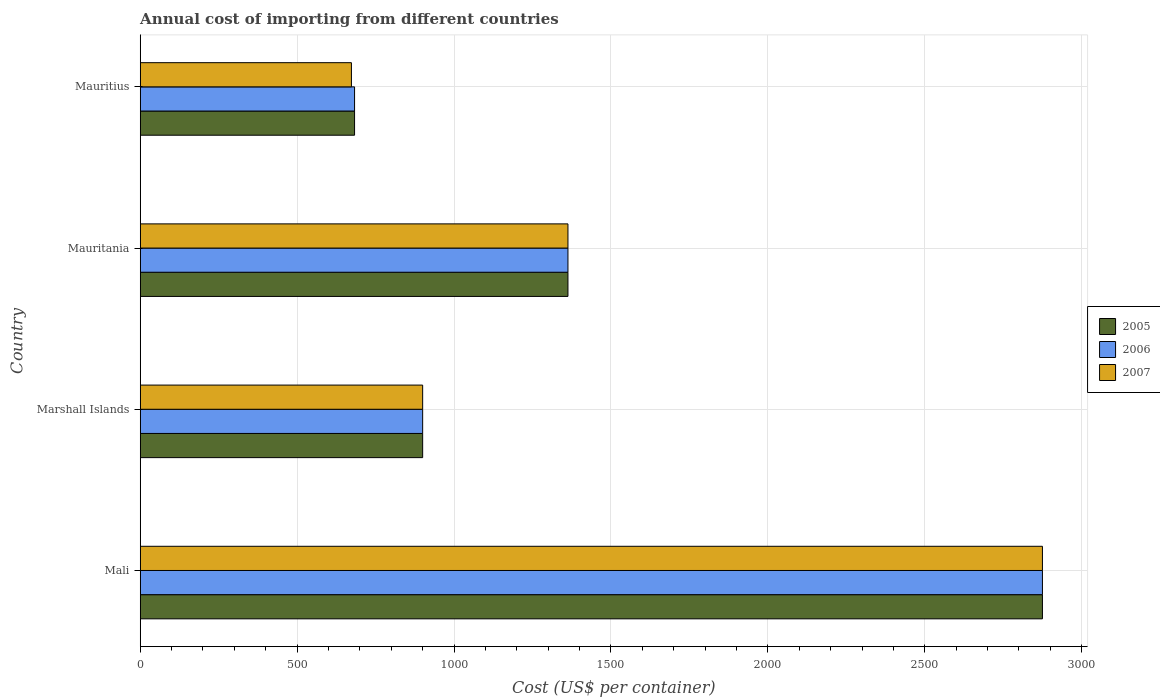How many different coloured bars are there?
Your answer should be very brief. 3. Are the number of bars on each tick of the Y-axis equal?
Your answer should be very brief. Yes. How many bars are there on the 4th tick from the top?
Keep it short and to the point. 3. How many bars are there on the 3rd tick from the bottom?
Give a very brief answer. 3. What is the label of the 4th group of bars from the top?
Provide a succinct answer. Mali. What is the total annual cost of importing in 2005 in Mauritius?
Your response must be concise. 683. Across all countries, what is the maximum total annual cost of importing in 2005?
Your response must be concise. 2875. Across all countries, what is the minimum total annual cost of importing in 2007?
Ensure brevity in your answer.  673. In which country was the total annual cost of importing in 2005 maximum?
Offer a very short reply. Mali. In which country was the total annual cost of importing in 2006 minimum?
Your response must be concise. Mauritius. What is the total total annual cost of importing in 2007 in the graph?
Give a very brief answer. 5811. What is the difference between the total annual cost of importing in 2007 in Mali and that in Marshall Islands?
Offer a terse response. 1975. What is the difference between the total annual cost of importing in 2005 in Mauritius and the total annual cost of importing in 2006 in Mali?
Offer a very short reply. -2192. What is the average total annual cost of importing in 2006 per country?
Give a very brief answer. 1455.25. What is the difference between the total annual cost of importing in 2006 and total annual cost of importing in 2005 in Mali?
Your answer should be compact. 0. In how many countries, is the total annual cost of importing in 2005 greater than 400 US$?
Keep it short and to the point. 4. What is the ratio of the total annual cost of importing in 2007 in Mali to that in Marshall Islands?
Your answer should be very brief. 3.19. Is the total annual cost of importing in 2007 in Marshall Islands less than that in Mauritania?
Provide a short and direct response. Yes. What is the difference between the highest and the second highest total annual cost of importing in 2007?
Make the answer very short. 1512. What is the difference between the highest and the lowest total annual cost of importing in 2007?
Give a very brief answer. 2202. What does the 2nd bar from the top in Marshall Islands represents?
Provide a short and direct response. 2006. Is it the case that in every country, the sum of the total annual cost of importing in 2005 and total annual cost of importing in 2006 is greater than the total annual cost of importing in 2007?
Make the answer very short. Yes. How many countries are there in the graph?
Provide a short and direct response. 4. Does the graph contain any zero values?
Your response must be concise. No. Does the graph contain grids?
Make the answer very short. Yes. How are the legend labels stacked?
Your answer should be very brief. Vertical. What is the title of the graph?
Keep it short and to the point. Annual cost of importing from different countries. Does "1969" appear as one of the legend labels in the graph?
Offer a very short reply. No. What is the label or title of the X-axis?
Provide a short and direct response. Cost (US$ per container). What is the label or title of the Y-axis?
Provide a short and direct response. Country. What is the Cost (US$ per container) in 2005 in Mali?
Ensure brevity in your answer.  2875. What is the Cost (US$ per container) in 2006 in Mali?
Ensure brevity in your answer.  2875. What is the Cost (US$ per container) of 2007 in Mali?
Provide a succinct answer. 2875. What is the Cost (US$ per container) in 2005 in Marshall Islands?
Your response must be concise. 900. What is the Cost (US$ per container) in 2006 in Marshall Islands?
Provide a short and direct response. 900. What is the Cost (US$ per container) in 2007 in Marshall Islands?
Give a very brief answer. 900. What is the Cost (US$ per container) of 2005 in Mauritania?
Your answer should be compact. 1363. What is the Cost (US$ per container) in 2006 in Mauritania?
Your response must be concise. 1363. What is the Cost (US$ per container) in 2007 in Mauritania?
Offer a terse response. 1363. What is the Cost (US$ per container) of 2005 in Mauritius?
Keep it short and to the point. 683. What is the Cost (US$ per container) in 2006 in Mauritius?
Offer a terse response. 683. What is the Cost (US$ per container) in 2007 in Mauritius?
Provide a short and direct response. 673. Across all countries, what is the maximum Cost (US$ per container) in 2005?
Your response must be concise. 2875. Across all countries, what is the maximum Cost (US$ per container) in 2006?
Your answer should be compact. 2875. Across all countries, what is the maximum Cost (US$ per container) in 2007?
Make the answer very short. 2875. Across all countries, what is the minimum Cost (US$ per container) in 2005?
Your response must be concise. 683. Across all countries, what is the minimum Cost (US$ per container) in 2006?
Offer a very short reply. 683. Across all countries, what is the minimum Cost (US$ per container) of 2007?
Offer a terse response. 673. What is the total Cost (US$ per container) in 2005 in the graph?
Keep it short and to the point. 5821. What is the total Cost (US$ per container) of 2006 in the graph?
Offer a very short reply. 5821. What is the total Cost (US$ per container) in 2007 in the graph?
Make the answer very short. 5811. What is the difference between the Cost (US$ per container) of 2005 in Mali and that in Marshall Islands?
Provide a succinct answer. 1975. What is the difference between the Cost (US$ per container) of 2006 in Mali and that in Marshall Islands?
Offer a terse response. 1975. What is the difference between the Cost (US$ per container) of 2007 in Mali and that in Marshall Islands?
Offer a very short reply. 1975. What is the difference between the Cost (US$ per container) in 2005 in Mali and that in Mauritania?
Make the answer very short. 1512. What is the difference between the Cost (US$ per container) in 2006 in Mali and that in Mauritania?
Ensure brevity in your answer.  1512. What is the difference between the Cost (US$ per container) in 2007 in Mali and that in Mauritania?
Provide a short and direct response. 1512. What is the difference between the Cost (US$ per container) in 2005 in Mali and that in Mauritius?
Offer a terse response. 2192. What is the difference between the Cost (US$ per container) in 2006 in Mali and that in Mauritius?
Ensure brevity in your answer.  2192. What is the difference between the Cost (US$ per container) in 2007 in Mali and that in Mauritius?
Ensure brevity in your answer.  2202. What is the difference between the Cost (US$ per container) of 2005 in Marshall Islands and that in Mauritania?
Your answer should be very brief. -463. What is the difference between the Cost (US$ per container) of 2006 in Marshall Islands and that in Mauritania?
Your answer should be compact. -463. What is the difference between the Cost (US$ per container) of 2007 in Marshall Islands and that in Mauritania?
Ensure brevity in your answer.  -463. What is the difference between the Cost (US$ per container) of 2005 in Marshall Islands and that in Mauritius?
Offer a terse response. 217. What is the difference between the Cost (US$ per container) in 2006 in Marshall Islands and that in Mauritius?
Your answer should be compact. 217. What is the difference between the Cost (US$ per container) in 2007 in Marshall Islands and that in Mauritius?
Give a very brief answer. 227. What is the difference between the Cost (US$ per container) in 2005 in Mauritania and that in Mauritius?
Give a very brief answer. 680. What is the difference between the Cost (US$ per container) of 2006 in Mauritania and that in Mauritius?
Keep it short and to the point. 680. What is the difference between the Cost (US$ per container) in 2007 in Mauritania and that in Mauritius?
Offer a very short reply. 690. What is the difference between the Cost (US$ per container) in 2005 in Mali and the Cost (US$ per container) in 2006 in Marshall Islands?
Your answer should be compact. 1975. What is the difference between the Cost (US$ per container) of 2005 in Mali and the Cost (US$ per container) of 2007 in Marshall Islands?
Give a very brief answer. 1975. What is the difference between the Cost (US$ per container) in 2006 in Mali and the Cost (US$ per container) in 2007 in Marshall Islands?
Keep it short and to the point. 1975. What is the difference between the Cost (US$ per container) of 2005 in Mali and the Cost (US$ per container) of 2006 in Mauritania?
Ensure brevity in your answer.  1512. What is the difference between the Cost (US$ per container) in 2005 in Mali and the Cost (US$ per container) in 2007 in Mauritania?
Give a very brief answer. 1512. What is the difference between the Cost (US$ per container) of 2006 in Mali and the Cost (US$ per container) of 2007 in Mauritania?
Keep it short and to the point. 1512. What is the difference between the Cost (US$ per container) in 2005 in Mali and the Cost (US$ per container) in 2006 in Mauritius?
Provide a short and direct response. 2192. What is the difference between the Cost (US$ per container) in 2005 in Mali and the Cost (US$ per container) in 2007 in Mauritius?
Your answer should be compact. 2202. What is the difference between the Cost (US$ per container) in 2006 in Mali and the Cost (US$ per container) in 2007 in Mauritius?
Make the answer very short. 2202. What is the difference between the Cost (US$ per container) of 2005 in Marshall Islands and the Cost (US$ per container) of 2006 in Mauritania?
Make the answer very short. -463. What is the difference between the Cost (US$ per container) in 2005 in Marshall Islands and the Cost (US$ per container) in 2007 in Mauritania?
Your answer should be very brief. -463. What is the difference between the Cost (US$ per container) of 2006 in Marshall Islands and the Cost (US$ per container) of 2007 in Mauritania?
Give a very brief answer. -463. What is the difference between the Cost (US$ per container) of 2005 in Marshall Islands and the Cost (US$ per container) of 2006 in Mauritius?
Provide a short and direct response. 217. What is the difference between the Cost (US$ per container) of 2005 in Marshall Islands and the Cost (US$ per container) of 2007 in Mauritius?
Offer a terse response. 227. What is the difference between the Cost (US$ per container) of 2006 in Marshall Islands and the Cost (US$ per container) of 2007 in Mauritius?
Offer a terse response. 227. What is the difference between the Cost (US$ per container) of 2005 in Mauritania and the Cost (US$ per container) of 2006 in Mauritius?
Your response must be concise. 680. What is the difference between the Cost (US$ per container) in 2005 in Mauritania and the Cost (US$ per container) in 2007 in Mauritius?
Provide a short and direct response. 690. What is the difference between the Cost (US$ per container) of 2006 in Mauritania and the Cost (US$ per container) of 2007 in Mauritius?
Your response must be concise. 690. What is the average Cost (US$ per container) in 2005 per country?
Make the answer very short. 1455.25. What is the average Cost (US$ per container) in 2006 per country?
Your answer should be very brief. 1455.25. What is the average Cost (US$ per container) of 2007 per country?
Make the answer very short. 1452.75. What is the difference between the Cost (US$ per container) of 2005 and Cost (US$ per container) of 2006 in Mali?
Give a very brief answer. 0. What is the difference between the Cost (US$ per container) in 2005 and Cost (US$ per container) in 2007 in Mali?
Ensure brevity in your answer.  0. What is the difference between the Cost (US$ per container) of 2006 and Cost (US$ per container) of 2007 in Mali?
Keep it short and to the point. 0. What is the difference between the Cost (US$ per container) in 2005 and Cost (US$ per container) in 2007 in Marshall Islands?
Offer a very short reply. 0. What is the difference between the Cost (US$ per container) of 2006 and Cost (US$ per container) of 2007 in Marshall Islands?
Give a very brief answer. 0. What is the difference between the Cost (US$ per container) in 2005 and Cost (US$ per container) in 2006 in Mauritania?
Provide a short and direct response. 0. What is the difference between the Cost (US$ per container) of 2005 and Cost (US$ per container) of 2006 in Mauritius?
Ensure brevity in your answer.  0. What is the difference between the Cost (US$ per container) in 2005 and Cost (US$ per container) in 2007 in Mauritius?
Provide a succinct answer. 10. What is the difference between the Cost (US$ per container) of 2006 and Cost (US$ per container) of 2007 in Mauritius?
Your answer should be compact. 10. What is the ratio of the Cost (US$ per container) in 2005 in Mali to that in Marshall Islands?
Make the answer very short. 3.19. What is the ratio of the Cost (US$ per container) in 2006 in Mali to that in Marshall Islands?
Provide a short and direct response. 3.19. What is the ratio of the Cost (US$ per container) in 2007 in Mali to that in Marshall Islands?
Your answer should be compact. 3.19. What is the ratio of the Cost (US$ per container) in 2005 in Mali to that in Mauritania?
Offer a very short reply. 2.11. What is the ratio of the Cost (US$ per container) in 2006 in Mali to that in Mauritania?
Give a very brief answer. 2.11. What is the ratio of the Cost (US$ per container) of 2007 in Mali to that in Mauritania?
Your response must be concise. 2.11. What is the ratio of the Cost (US$ per container) of 2005 in Mali to that in Mauritius?
Offer a very short reply. 4.21. What is the ratio of the Cost (US$ per container) of 2006 in Mali to that in Mauritius?
Ensure brevity in your answer.  4.21. What is the ratio of the Cost (US$ per container) of 2007 in Mali to that in Mauritius?
Ensure brevity in your answer.  4.27. What is the ratio of the Cost (US$ per container) of 2005 in Marshall Islands to that in Mauritania?
Keep it short and to the point. 0.66. What is the ratio of the Cost (US$ per container) in 2006 in Marshall Islands to that in Mauritania?
Your response must be concise. 0.66. What is the ratio of the Cost (US$ per container) in 2007 in Marshall Islands to that in Mauritania?
Provide a short and direct response. 0.66. What is the ratio of the Cost (US$ per container) in 2005 in Marshall Islands to that in Mauritius?
Offer a terse response. 1.32. What is the ratio of the Cost (US$ per container) of 2006 in Marshall Islands to that in Mauritius?
Give a very brief answer. 1.32. What is the ratio of the Cost (US$ per container) in 2007 in Marshall Islands to that in Mauritius?
Provide a short and direct response. 1.34. What is the ratio of the Cost (US$ per container) in 2005 in Mauritania to that in Mauritius?
Your response must be concise. 2. What is the ratio of the Cost (US$ per container) of 2006 in Mauritania to that in Mauritius?
Your answer should be compact. 2. What is the ratio of the Cost (US$ per container) of 2007 in Mauritania to that in Mauritius?
Make the answer very short. 2.03. What is the difference between the highest and the second highest Cost (US$ per container) of 2005?
Your response must be concise. 1512. What is the difference between the highest and the second highest Cost (US$ per container) in 2006?
Your answer should be compact. 1512. What is the difference between the highest and the second highest Cost (US$ per container) in 2007?
Offer a very short reply. 1512. What is the difference between the highest and the lowest Cost (US$ per container) in 2005?
Your answer should be compact. 2192. What is the difference between the highest and the lowest Cost (US$ per container) of 2006?
Your answer should be very brief. 2192. What is the difference between the highest and the lowest Cost (US$ per container) of 2007?
Make the answer very short. 2202. 